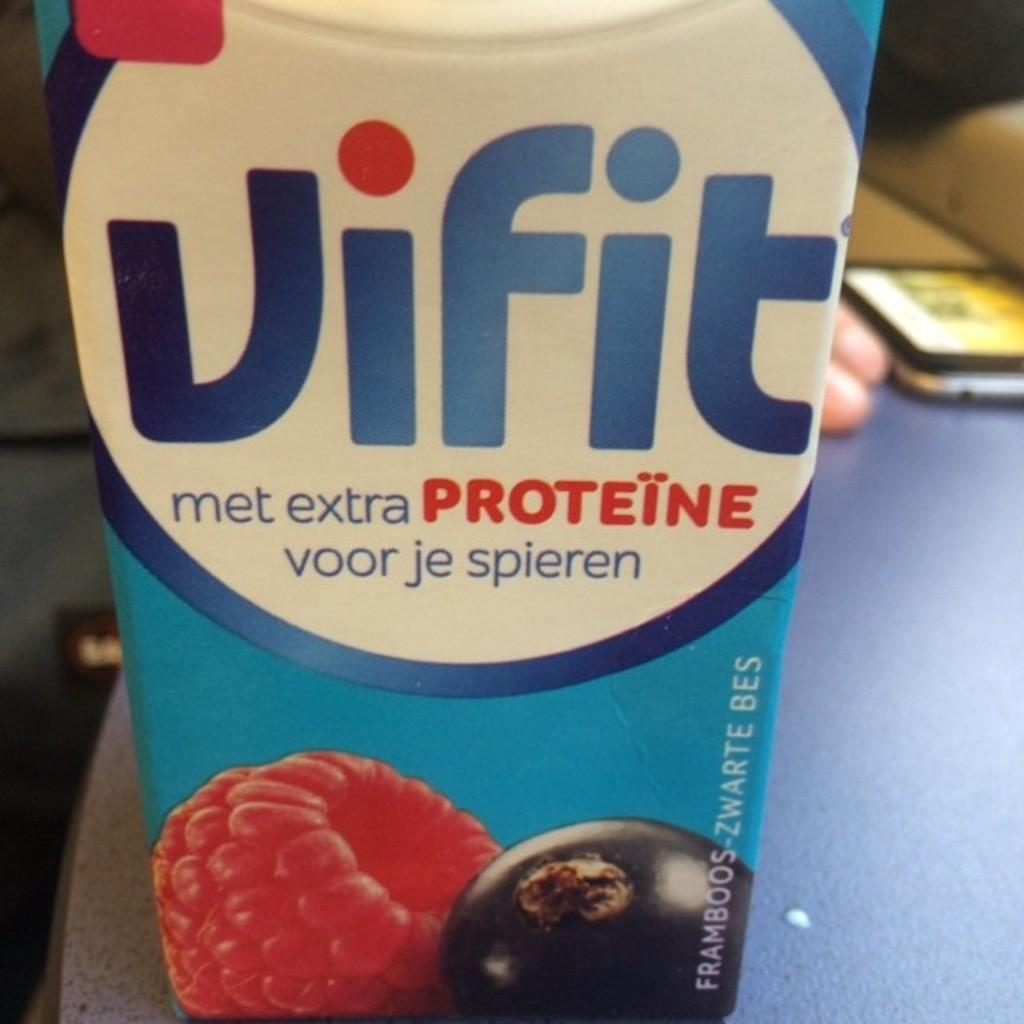<image>
Provide a brief description of the given image. a close up of a box of Vifit met extra Proteine 